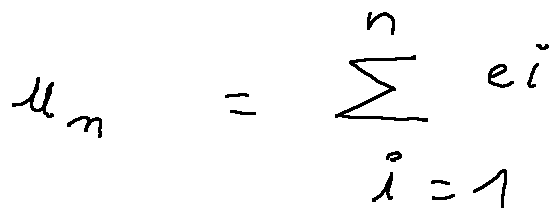Convert formula to latex. <formula><loc_0><loc_0><loc_500><loc_500>u _ { n } = \sum \lim i t s _ { i = 1 } ^ { n } e _ { i }</formula> 